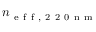<formula> <loc_0><loc_0><loc_500><loc_500>n _ { e f f , 2 2 0 n m }</formula> 